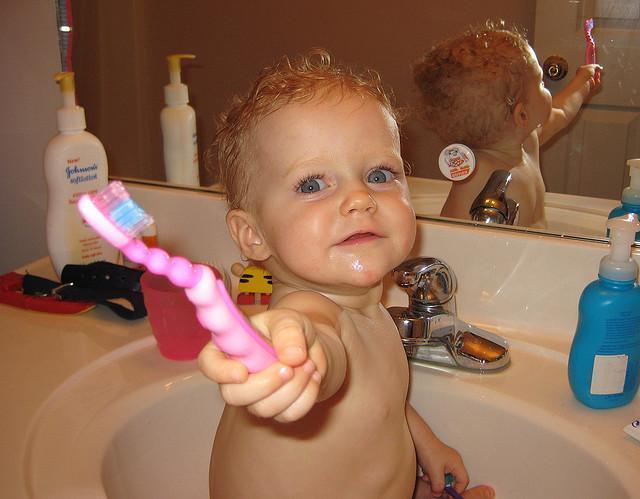How many people are there?
Give a very brief answer. 2. How many black dogs are there?
Give a very brief answer. 0. 